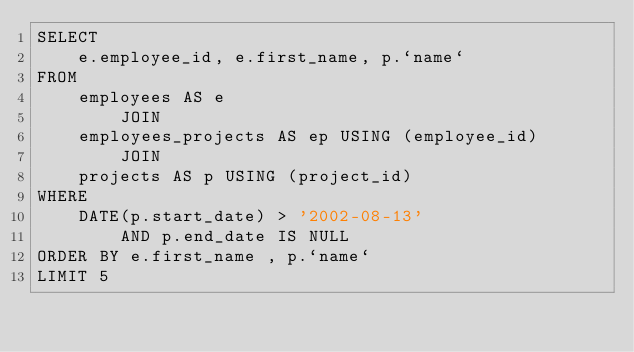<code> <loc_0><loc_0><loc_500><loc_500><_SQL_>SELECT 
    e.employee_id, e.first_name, p.`name`
FROM
    employees AS e
        JOIN
    employees_projects AS ep USING (employee_id)
        JOIN
    projects AS p USING (project_id)
WHERE
    DATE(p.start_date) > '2002-08-13'
        AND p.end_date IS NULL
ORDER BY e.first_name , p.`name`
LIMIT 5</code> 